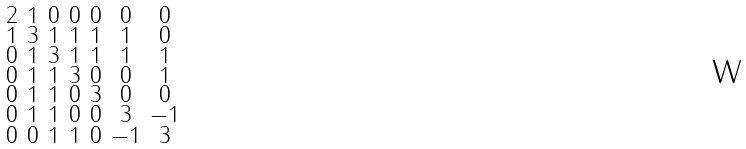<formula> <loc_0><loc_0><loc_500><loc_500>\begin{smallmatrix} 2 & 1 & 0 & 0 & 0 & 0 & 0 \\ 1 & 3 & 1 & 1 & 1 & 1 & 0 \\ 0 & 1 & 3 & 1 & 1 & 1 & 1 \\ 0 & 1 & 1 & 3 & 0 & 0 & 1 \\ 0 & 1 & 1 & 0 & 3 & 0 & 0 \\ 0 & 1 & 1 & 0 & 0 & 3 & - 1 \\ 0 & 0 & 1 & 1 & 0 & - 1 & 3 \end{smallmatrix}</formula> 